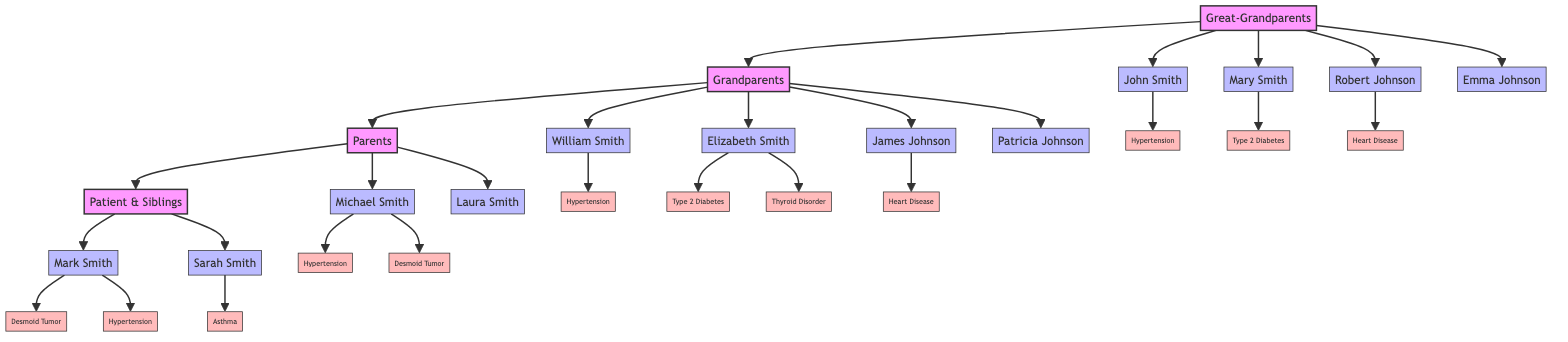What health condition is associated with Mark Smith? The diagram shows that Mark Smith has "Desmoid Tumor" along with "Hypertension" as his health conditions.
Answer: Desmoid Tumor How many generations are represented in the family tree? The diagram contains four generations: Great-Grandparents, Grandparents, Parents, and Patient & Siblings.
Answer: Four Who is the Great-Grandmother of Mark Smith? The diagram indicates that Mary Smith is the Great-Grandmother of Mark Smith, being a member of the Great-Grandparents generation.
Answer: Mary Smith What is the only health condition listed for Patricia Johnson? The diagram indicates that Patricia Johnson has "None" listed under her health conditions, denoting no known health issues.
Answer: None Which of the patient's parents has Desmoid Tumor? The diagram specifies that Michael Smith, the father of Mark Smith, has a Desmoid Tumor as one of his health conditions.
Answer: Michael Smith How many family members in the diagram have Hypertension? By reviewing the health conditions, John Smith, William Smith, Michael Smith, and Mark Smith have Hypertension, totaling four family members.
Answer: Four What health conditions are associated with Elizabeth Smith? The diagram shows that Elizabeth Smith has "Type 2 Diabetes" and "Thyroid Disorder" as her health conditions.
Answer: Type 2 Diabetes, Thyroid Disorder What is the relationship between Laura Smith and Mark Smith? The diagram indicates that Laura Smith is Mark Smith's mother, connecting them in the family tree as parent and child.
Answer: Mother Which member has no known health conditions? The diagram highlights that Emma Johnson and Patricia Johnson both have no health conditions listed, but Patricia Johnson is directly mentioned as a member with the title "Grandmother."
Answer: Patricia Johnson 